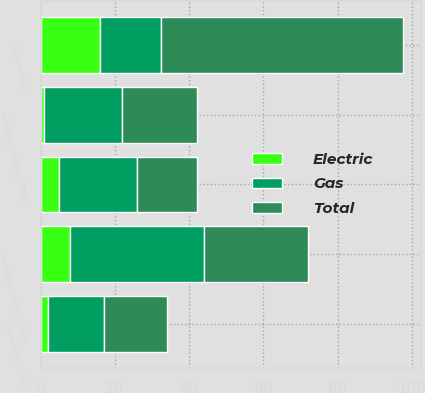<chart> <loc_0><loc_0><loc_500><loc_500><stacked_bar_chart><ecel><fcel>Distribution rates increase<fcel>Commodity margin<fcel>Regulatory program cost<fcel>Other<fcel>Total increase<nl><fcel>Total<fcel>28<fcel>17<fcel>20<fcel>16<fcel>65<nl><fcel>Electric<fcel>8<fcel>2<fcel>1<fcel>5<fcel>16<nl><fcel>Gas<fcel>36<fcel>15<fcel>21<fcel>21<fcel>16.5<nl></chart> 